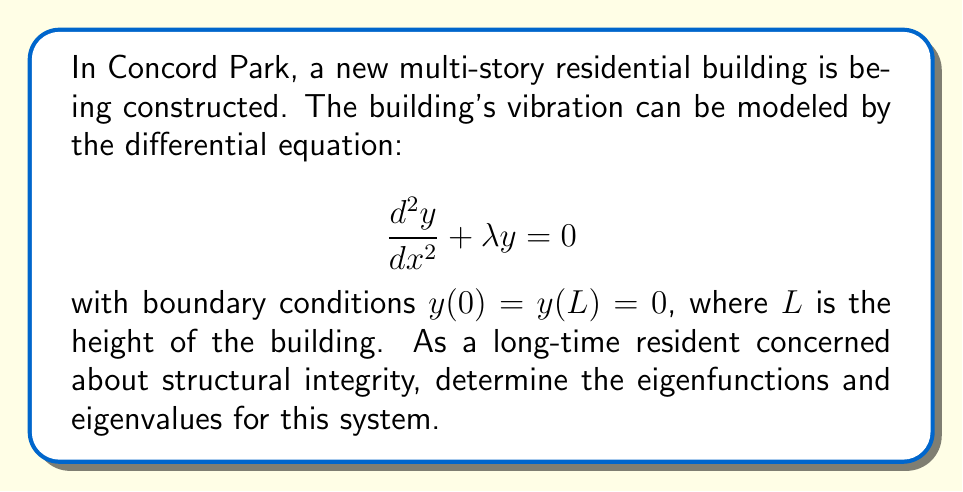What is the answer to this math problem? 1. The given differential equation is a second-order linear homogeneous equation with constant coefficients. Its general solution is:

   $$y(x) = A \sin(\sqrt{\lambda}x) + B \cos(\sqrt{\lambda}x)$$

2. Apply the boundary condition $y(0) = 0$:
   $$y(0) = A \sin(0) + B \cos(0) = B = 0$$

3. This simplifies our solution to:
   $$y(x) = A \sin(\sqrt{\lambda}x)$$

4. Now apply the second boundary condition $y(L) = 0$:
   $$y(L) = A \sin(\sqrt{\lambda}L) = 0$$

5. For this to be true (and for non-trivial solutions where $A \neq 0$), we must have:
   $$\sqrt{\lambda}L = n\pi, \quad n = 1, 2, 3, ...$$

6. Solving for $\lambda$:
   $$\lambda_n = \frac{n^2\pi^2}{L^2}, \quad n = 1, 2, 3, ...$$

7. The corresponding eigenfunctions are:
   $$y_n(x) = A_n \sin(\frac{n\pi x}{L}), \quad n = 1, 2, 3, ...$$

   where $A_n$ are arbitrary constants.

8. These eigenfunctions represent the possible vibration modes of the building, with $n$ corresponding to the number of nodes in each mode.
Answer: Eigenfunctions: $y_n(x) = A_n \sin(\frac{n\pi x}{L})$, Eigenvalues: $\lambda_n = \frac{n^2\pi^2}{L^2}$, where $n = 1, 2, 3, ...$ 